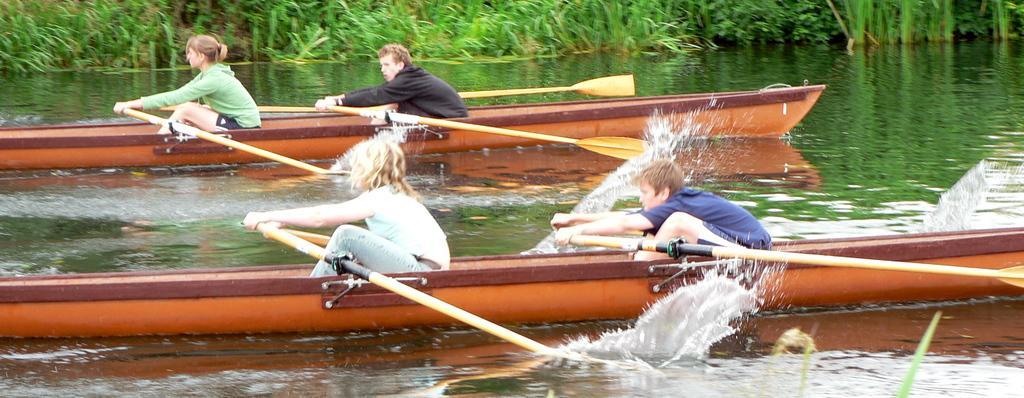How would you summarize this image in a sentence or two? In the picture,there are two boats and on each boat there are two people and they are sailing by their own and in the background there are some plants. 